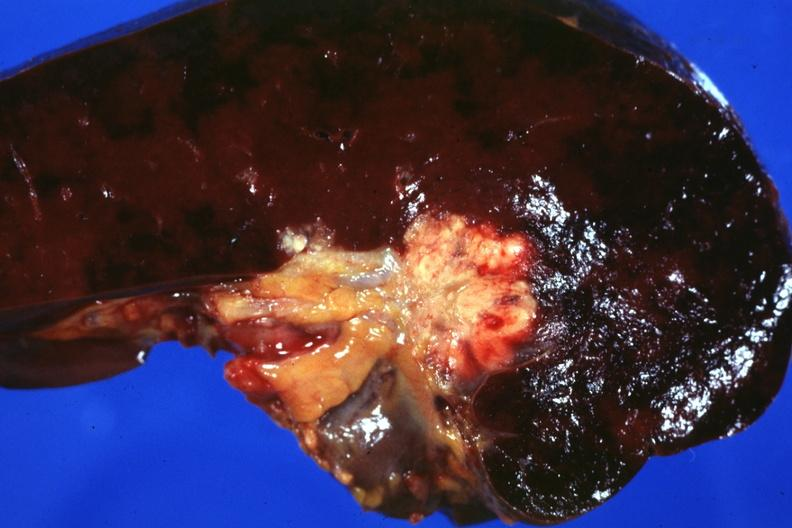what show tumor mass in hilum slide and large metastatic nodules in spleen?
Answer the question using a single word or phrase. Section of through 